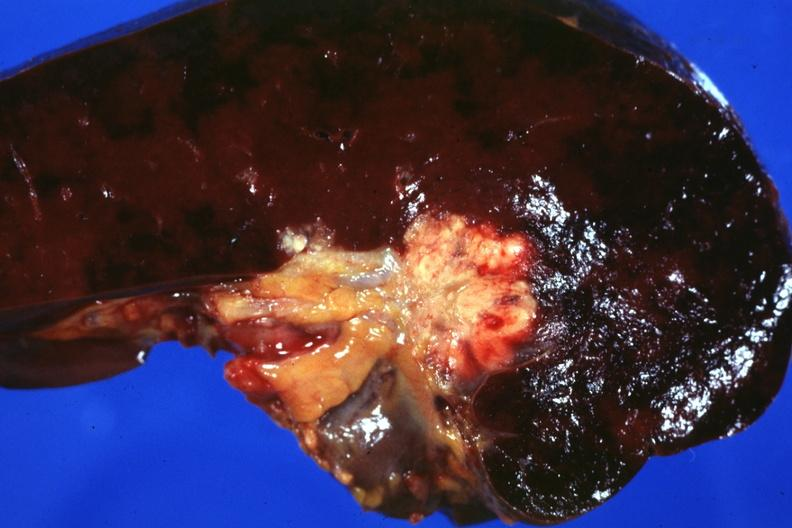what show tumor mass in hilum slide and large metastatic nodules in spleen?
Answer the question using a single word or phrase. Section of through 